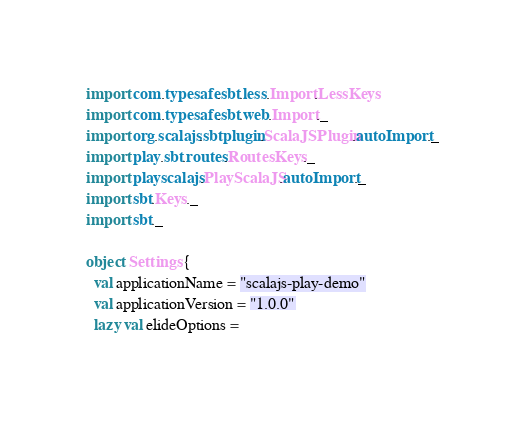<code> <loc_0><loc_0><loc_500><loc_500><_Scala_>import com.typesafe.sbt.less.Import.LessKeys
import com.typesafe.sbt.web.Import._
import org.scalajs.sbtplugin.ScalaJSPlugin.autoImport._
import play.sbt.routes.RoutesKeys._
import playscalajs.PlayScalaJS.autoImport._
import sbt.Keys._
import sbt._

object Settings {
  val applicationName = "scalajs-play-demo"
  val applicationVersion = "1.0.0"
  lazy val elideOptions =</code> 